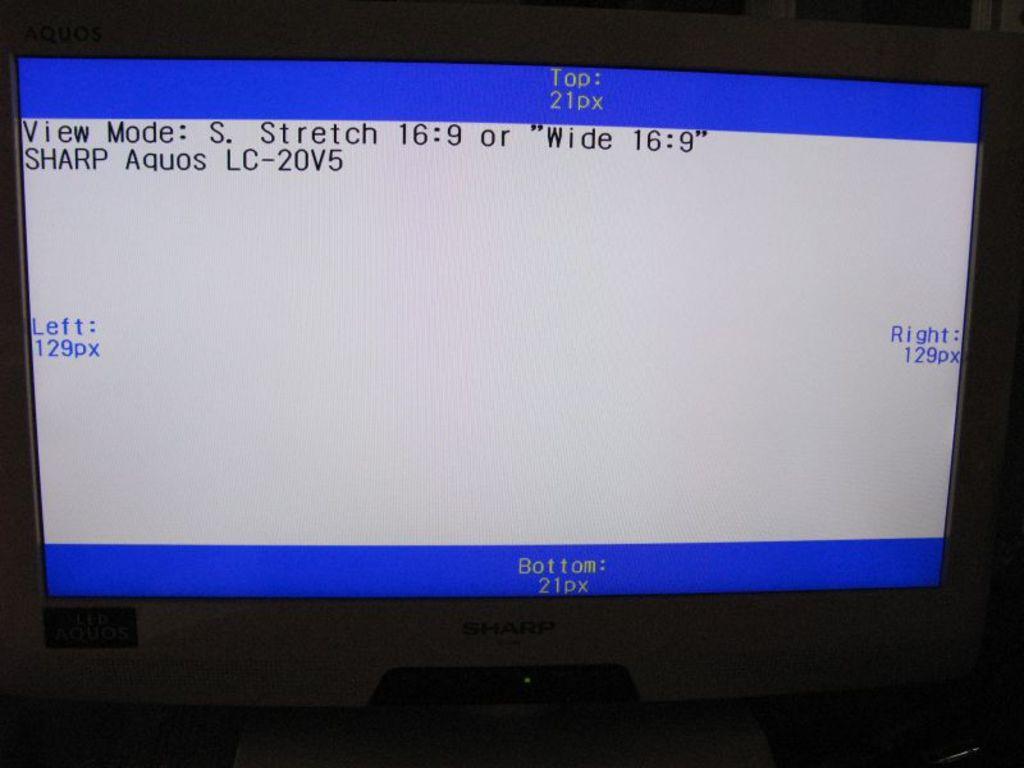What type of view mode is the monitor in?
Keep it short and to the point. Stretch. 